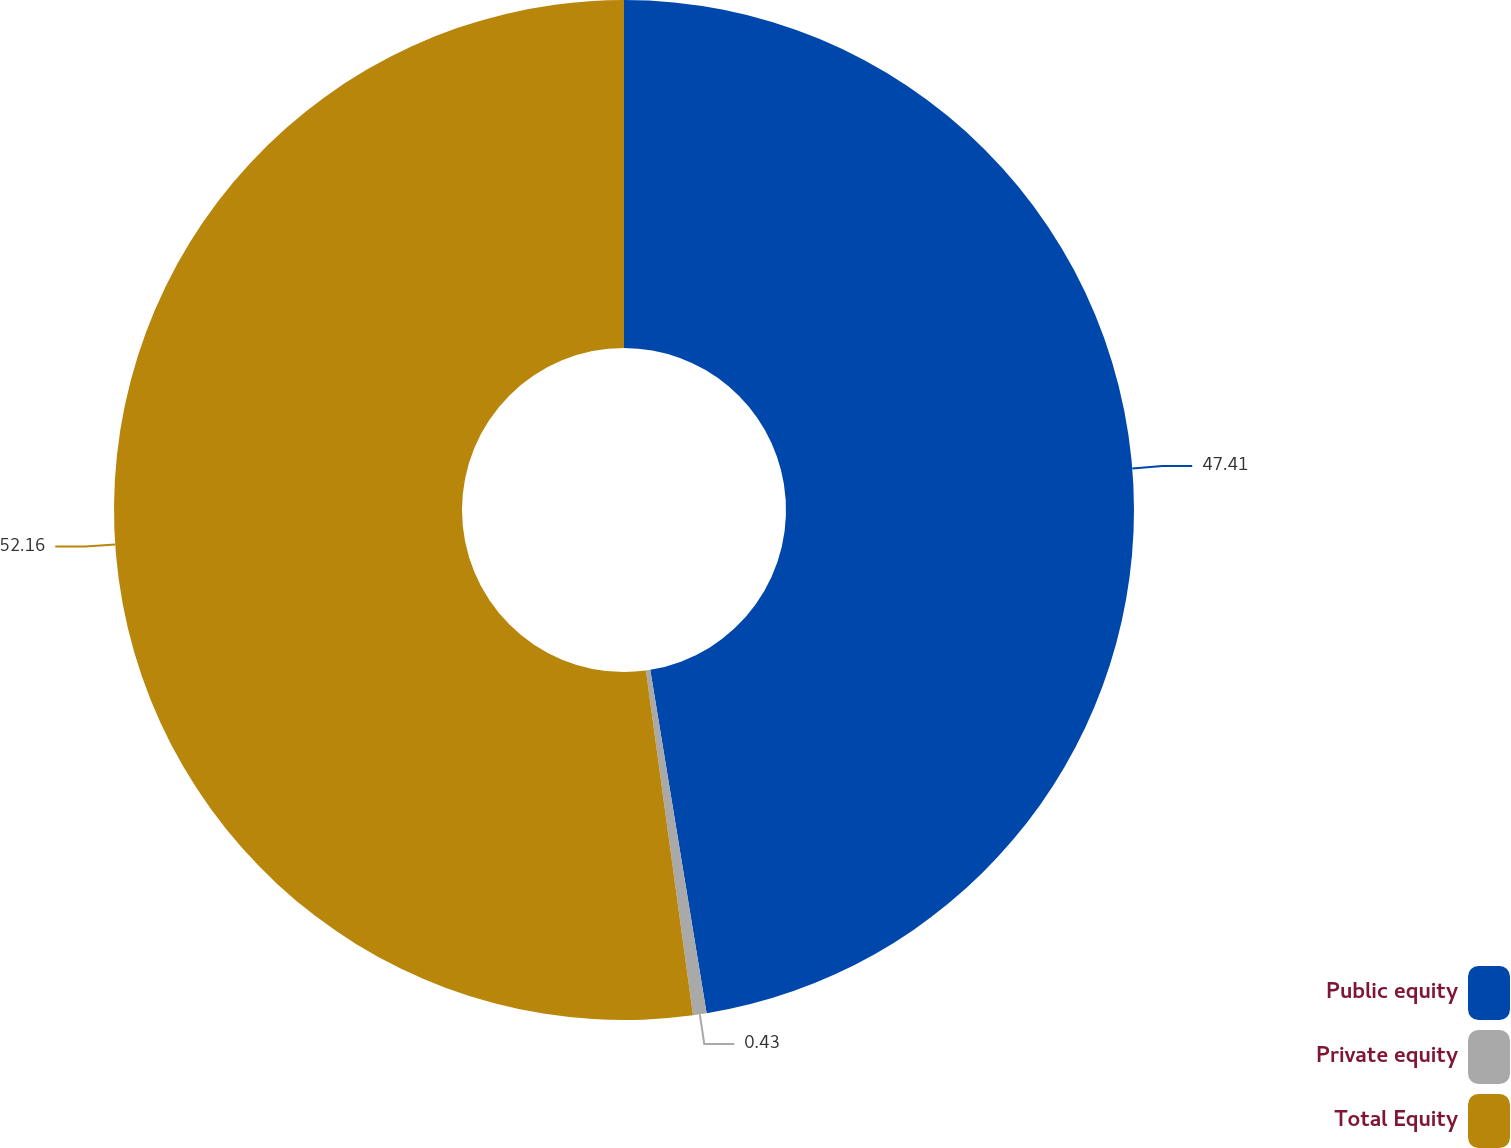<chart> <loc_0><loc_0><loc_500><loc_500><pie_chart><fcel>Public equity<fcel>Private equity<fcel>Total Equity<nl><fcel>47.41%<fcel>0.43%<fcel>52.16%<nl></chart> 